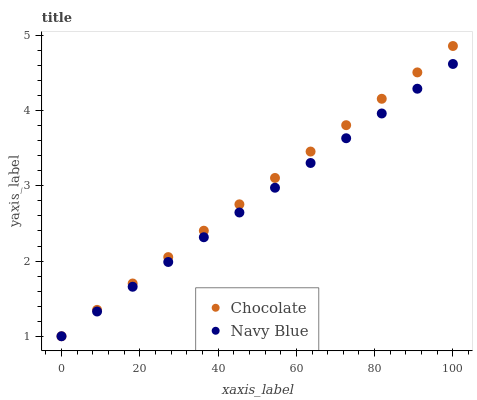Does Navy Blue have the minimum area under the curve?
Answer yes or no. Yes. Does Chocolate have the maximum area under the curve?
Answer yes or no. Yes. Does Chocolate have the minimum area under the curve?
Answer yes or no. No. Is Navy Blue the smoothest?
Answer yes or no. Yes. Is Chocolate the roughest?
Answer yes or no. Yes. Is Chocolate the smoothest?
Answer yes or no. No. Does Navy Blue have the lowest value?
Answer yes or no. Yes. Does Chocolate have the highest value?
Answer yes or no. Yes. Does Chocolate intersect Navy Blue?
Answer yes or no. Yes. Is Chocolate less than Navy Blue?
Answer yes or no. No. Is Chocolate greater than Navy Blue?
Answer yes or no. No. 